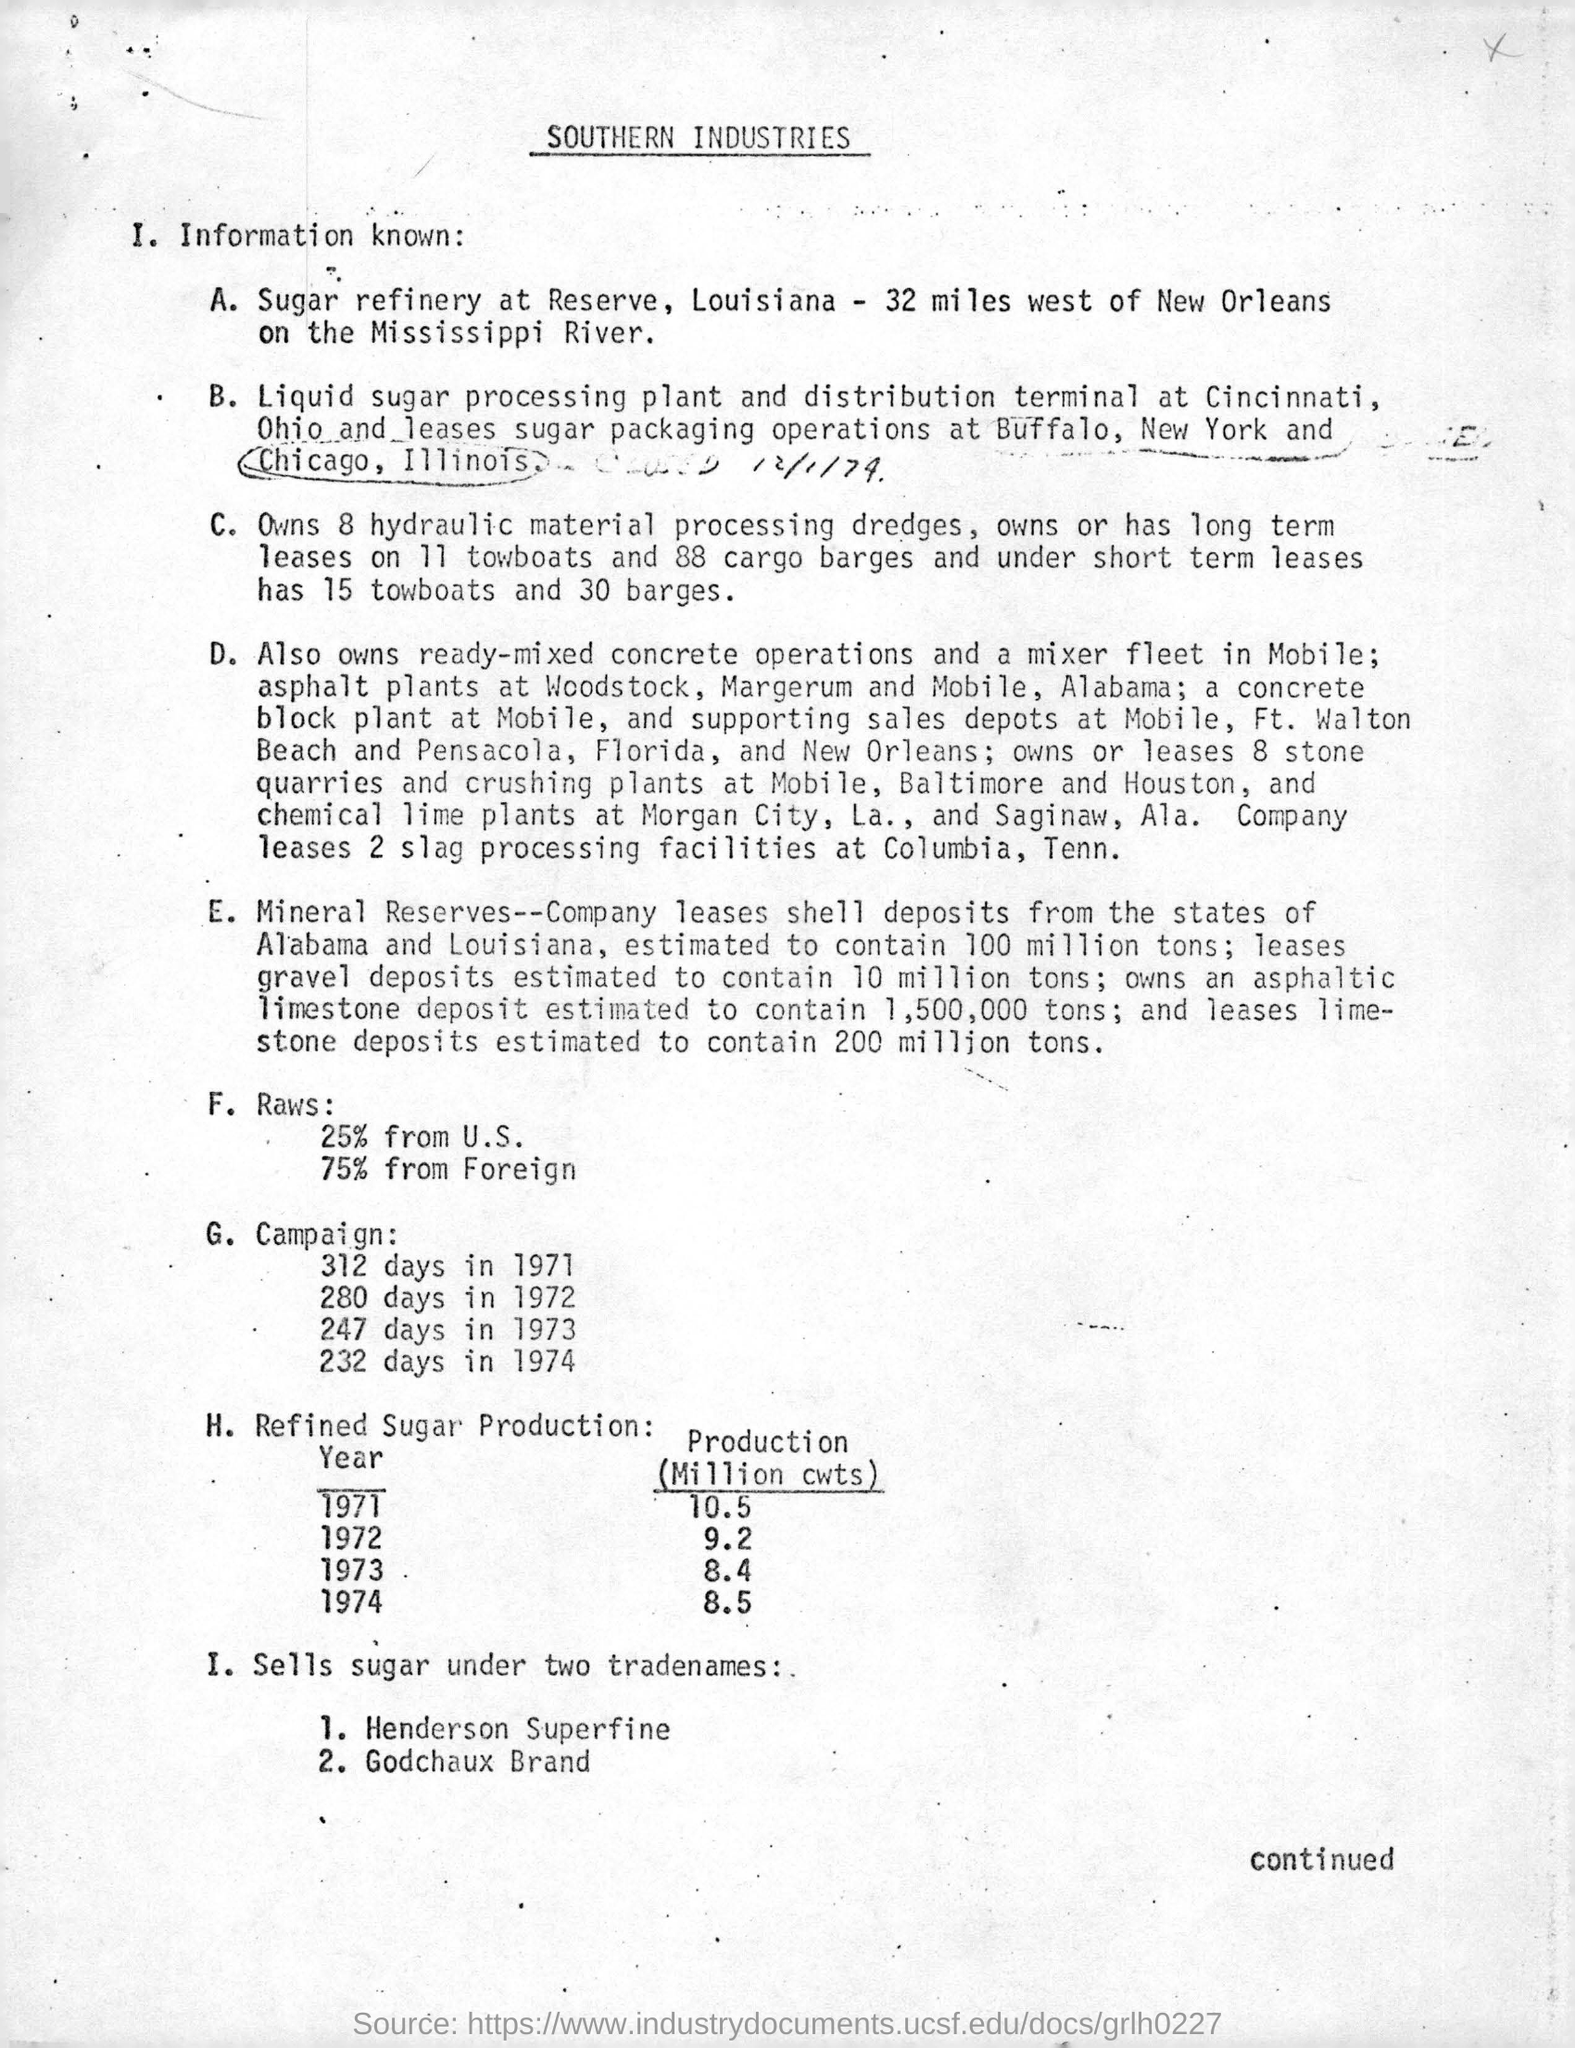Give some essential details in this illustration. In 1974, the production of refined sugar was 8.5. We own eight hydraulic material processing dredges. In the year 1971, the production of refined sugar was 10.5 million cwts. In 1973, the production of refined sugar was at its lowest, with a million cwts produced. 